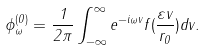<formula> <loc_0><loc_0><loc_500><loc_500>\phi ^ { ( 0 ) } _ { \omega } = \frac { 1 } { 2 \pi } \int ^ { \infty } _ { - \infty } e ^ { - i \omega v } f ( \frac { \varepsilon v } { r _ { 0 } } ) d v .</formula> 